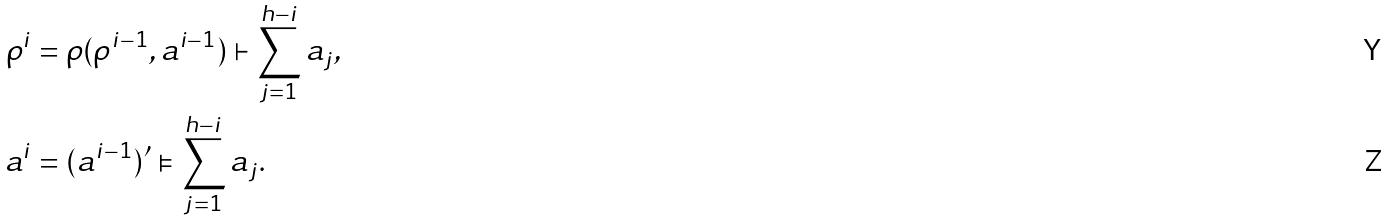Convert formula to latex. <formula><loc_0><loc_0><loc_500><loc_500>\rho ^ { i } & = \rho ( \rho ^ { i - 1 } , a ^ { i - 1 } ) \vdash \sum _ { j = 1 } ^ { h - i } a _ { j } , \\ a ^ { i } & = ( a ^ { i - 1 } ) ^ { \prime } \vDash \sum _ { j = 1 } ^ { h - i } a _ { j } .</formula> 